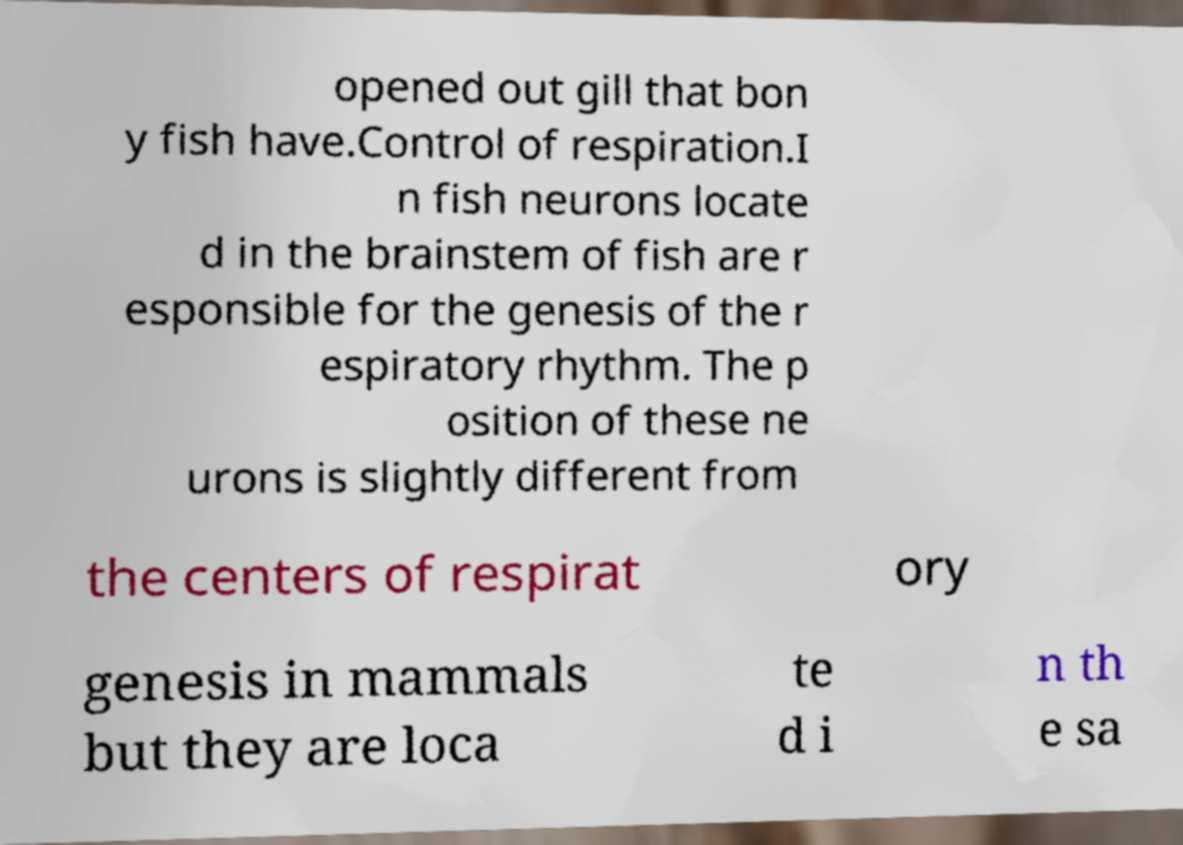For documentation purposes, I need the text within this image transcribed. Could you provide that? opened out gill that bon y fish have.Control of respiration.I n fish neurons locate d in the brainstem of fish are r esponsible for the genesis of the r espiratory rhythm. The p osition of these ne urons is slightly different from the centers of respirat ory genesis in mammals but they are loca te d i n th e sa 